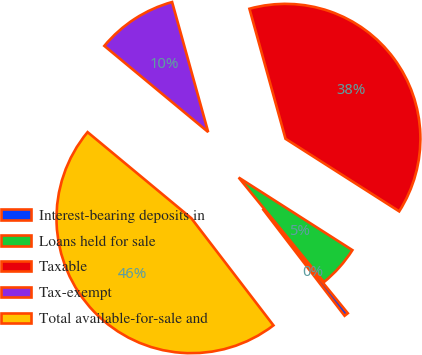<chart> <loc_0><loc_0><loc_500><loc_500><pie_chart><fcel>Interest-bearing deposits in<fcel>Loans held for sale<fcel>Taxable<fcel>Tax-exempt<fcel>Total available-for-sale and<nl><fcel>0.48%<fcel>5.07%<fcel>38.35%<fcel>9.67%<fcel>46.43%<nl></chart> 